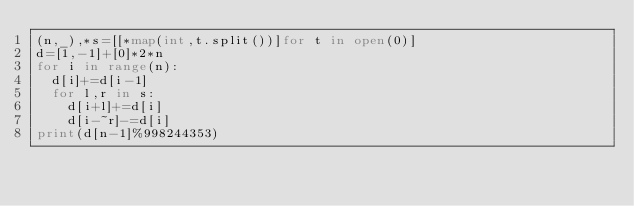<code> <loc_0><loc_0><loc_500><loc_500><_Python_>(n,_),*s=[[*map(int,t.split())]for t in open(0)]
d=[1,-1]+[0]*2*n
for i in range(n):
  d[i]+=d[i-1]
  for l,r in s:
    d[i+l]+=d[i]
    d[i-~r]-=d[i]
print(d[n-1]%998244353)</code> 